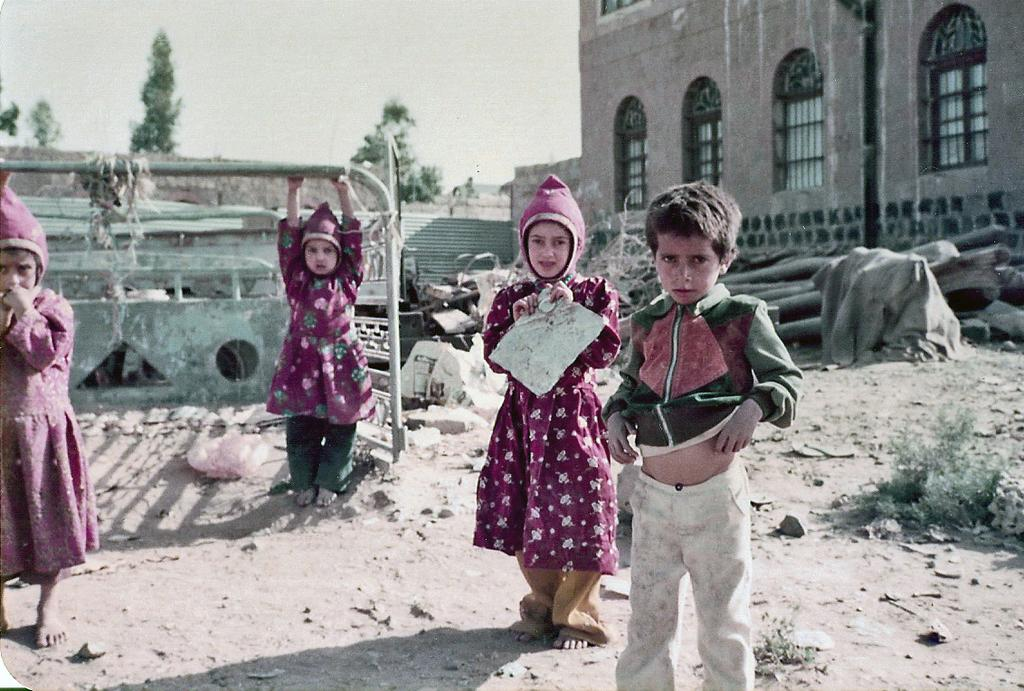What is the location of the kids in the image? The kids are standing on a land in the image. What can be seen in the background of the image? In the background of the image, there are materials, a house, trees, and the sky. What is the kid holding in the image? The kid is holding a pipe in the image. What type of quartz can be seen in the image? There is no quartz present in the image. Is there any honey visible in the image? There is no honey visible in the image. 